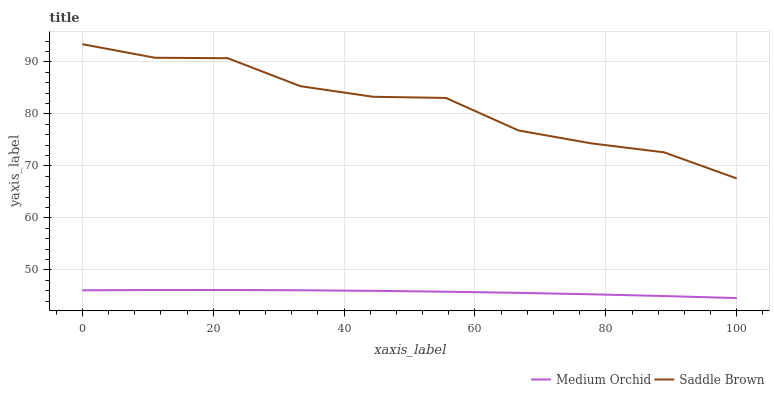Does Medium Orchid have the minimum area under the curve?
Answer yes or no. Yes. Does Saddle Brown have the maximum area under the curve?
Answer yes or no. Yes. Does Saddle Brown have the minimum area under the curve?
Answer yes or no. No. Is Medium Orchid the smoothest?
Answer yes or no. Yes. Is Saddle Brown the roughest?
Answer yes or no. Yes. Is Saddle Brown the smoothest?
Answer yes or no. No. Does Medium Orchid have the lowest value?
Answer yes or no. Yes. Does Saddle Brown have the lowest value?
Answer yes or no. No. Does Saddle Brown have the highest value?
Answer yes or no. Yes. Is Medium Orchid less than Saddle Brown?
Answer yes or no. Yes. Is Saddle Brown greater than Medium Orchid?
Answer yes or no. Yes. Does Medium Orchid intersect Saddle Brown?
Answer yes or no. No. 